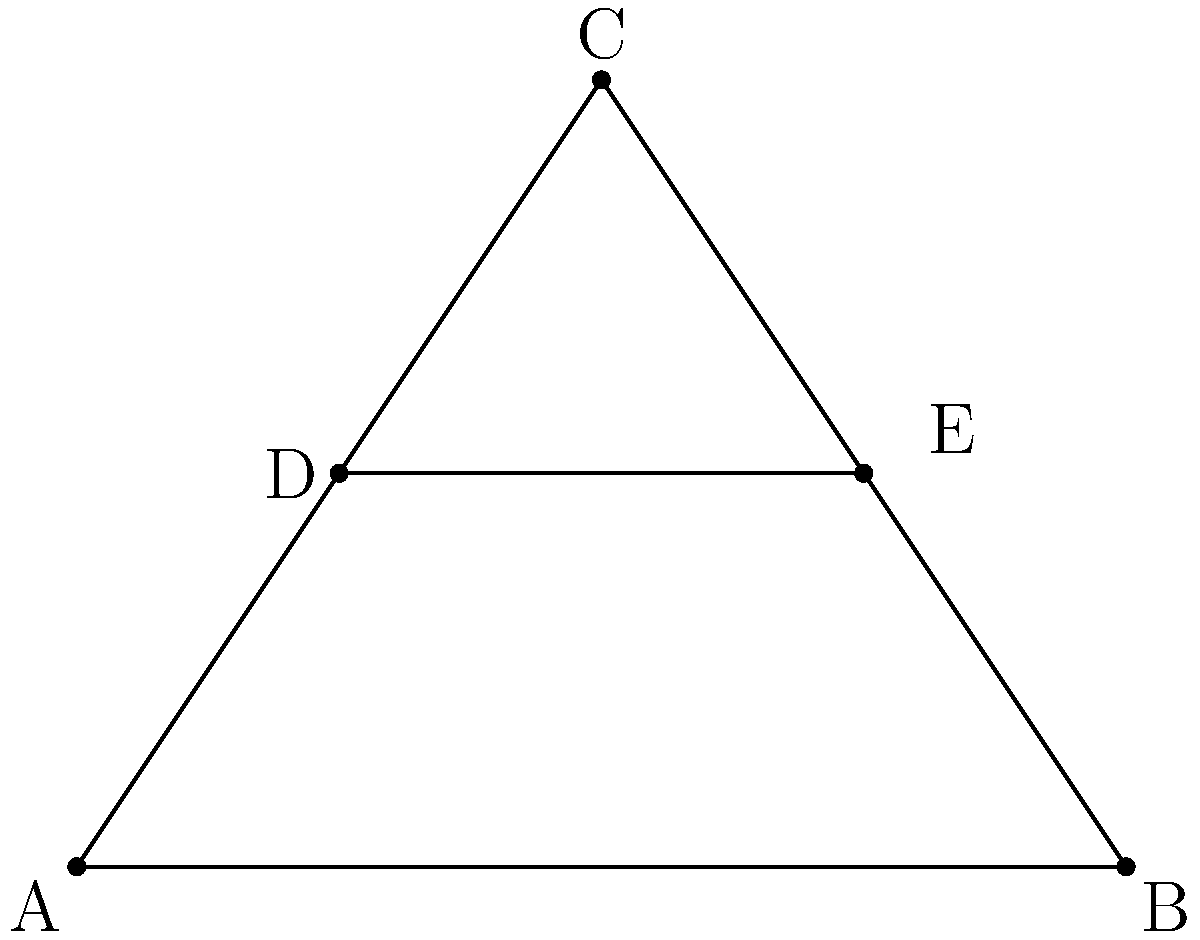In the diagram, triangle ABC represents the head of a tennis racket. DE is parallel to AB. If AD = 1 cm, DB = 3 cm, and DE = 2 cm, what is the length of AB? Let's approach this step-by-step:

1) First, we need to recognize that triangles ADE and ABC are similar due to the following:
   - Angle A is shared between both triangles
   - DE is parallel to AB, so the corresponding angles are equal

2) In similar triangles, the ratio of corresponding sides is constant. Let's call this ratio r. We can write:

   $$r = \frac{AD}{AB} = \frac{DE}{AB}$$

3) We know that AD = 1 cm and DB = 3 cm, so AB = AD + DB = 1 + 3 = 4 cm

4) We can now set up the proportion:

   $$\frac{DE}{AB} = \frac{2}{4} = \frac{1}{2}$$

5) To verify, we can check if this ratio holds for AD:AB

   $$\frac{AD}{AB} = \frac{1}{4} = \frac{1}{2}$$

6) The ratio checks out, confirming that AB is indeed 4 cm long.
Answer: 4 cm 